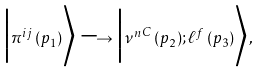Convert formula to latex. <formula><loc_0><loc_0><loc_500><loc_500>\Big | \pi ^ { i j } \, ( p _ { 1 } ) \Big \rangle \longrightarrow \Big | { { \nu } ^ { n } } ^ { C } \, ( p _ { 2 } ) ; \ell ^ { f } \, ( p _ { 3 } ) \Big \rangle ,</formula> 